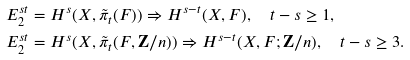<formula> <loc_0><loc_0><loc_500><loc_500>E ^ { s t } _ { 2 } & = H ^ { s } ( X , \tilde { \pi } _ { t } ( F ) ) \Rightarrow H ^ { s - t } ( X , F ) , \quad t - s \geq 1 , \\ E ^ { s t } _ { 2 } & = H ^ { s } ( X , \tilde { \pi } _ { t } ( F , { \mathbf Z } / n ) ) \Rightarrow H ^ { s - t } ( X , F ; { \mathbf Z } / n ) , \quad t - s \geq 3 .</formula> 